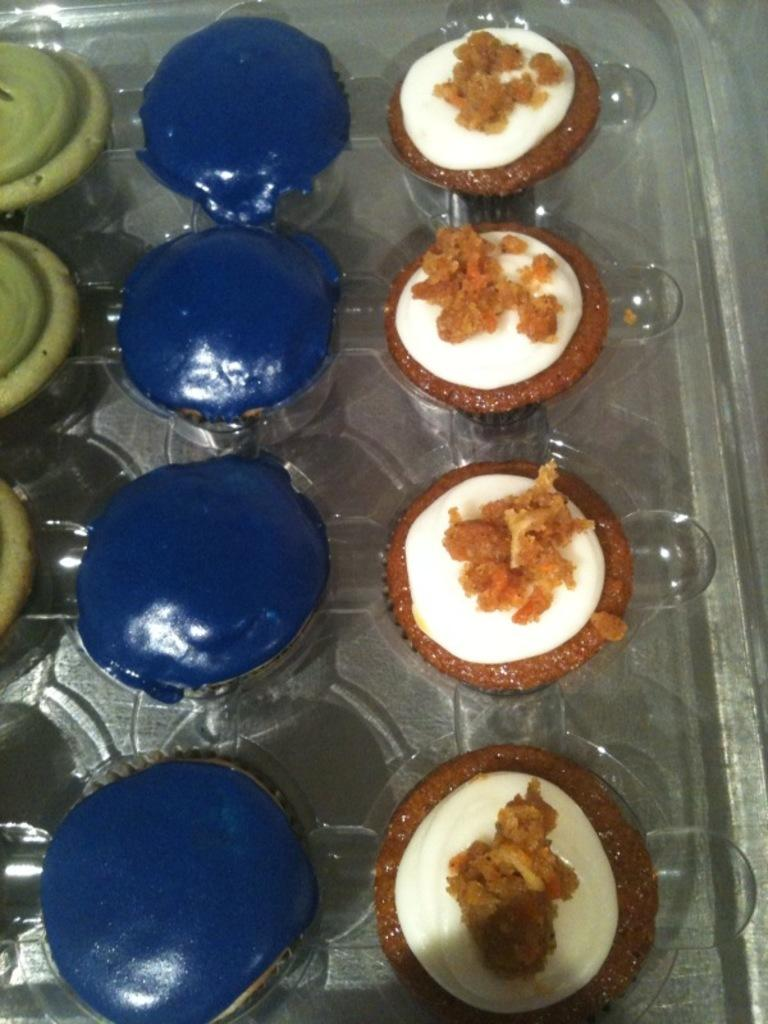What object is present in the image that can hold multiple items? There is a tray in the image. What type of items can be seen on the tray? The tray contains desserts. What time is it in the image? The time is not visible or mentioned in the image, so it cannot be determined. What force is being applied to the desserts on the tray? There is no indication of any force being applied to the desserts in the image; they are simply sitting on the tray. 